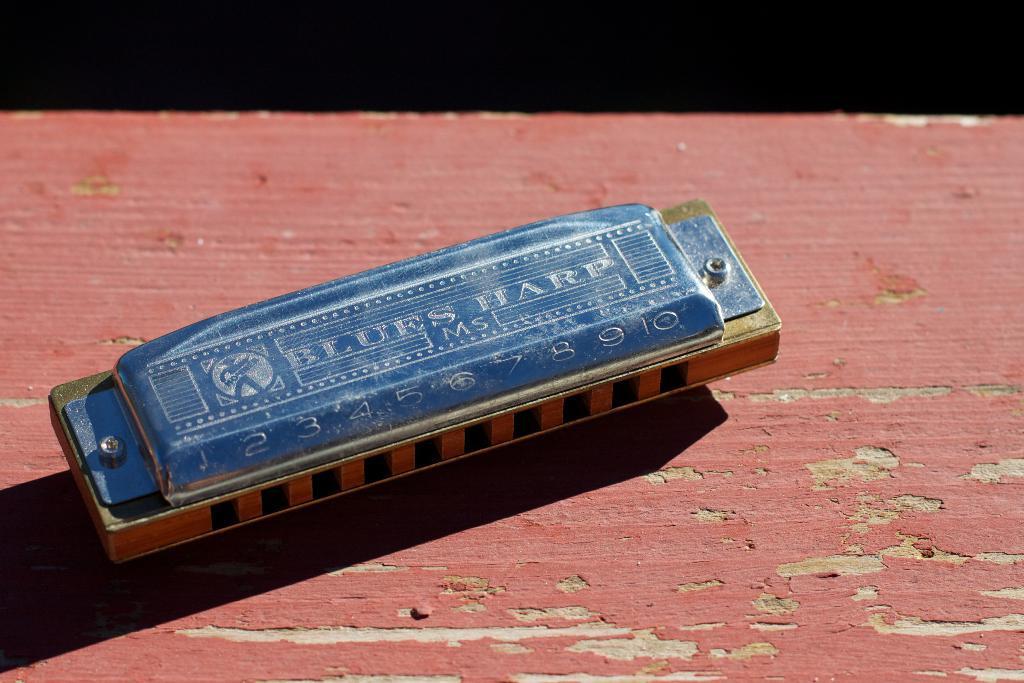In one or two sentences, can you explain what this image depicts? In this image we can see a harmonica on the table. 